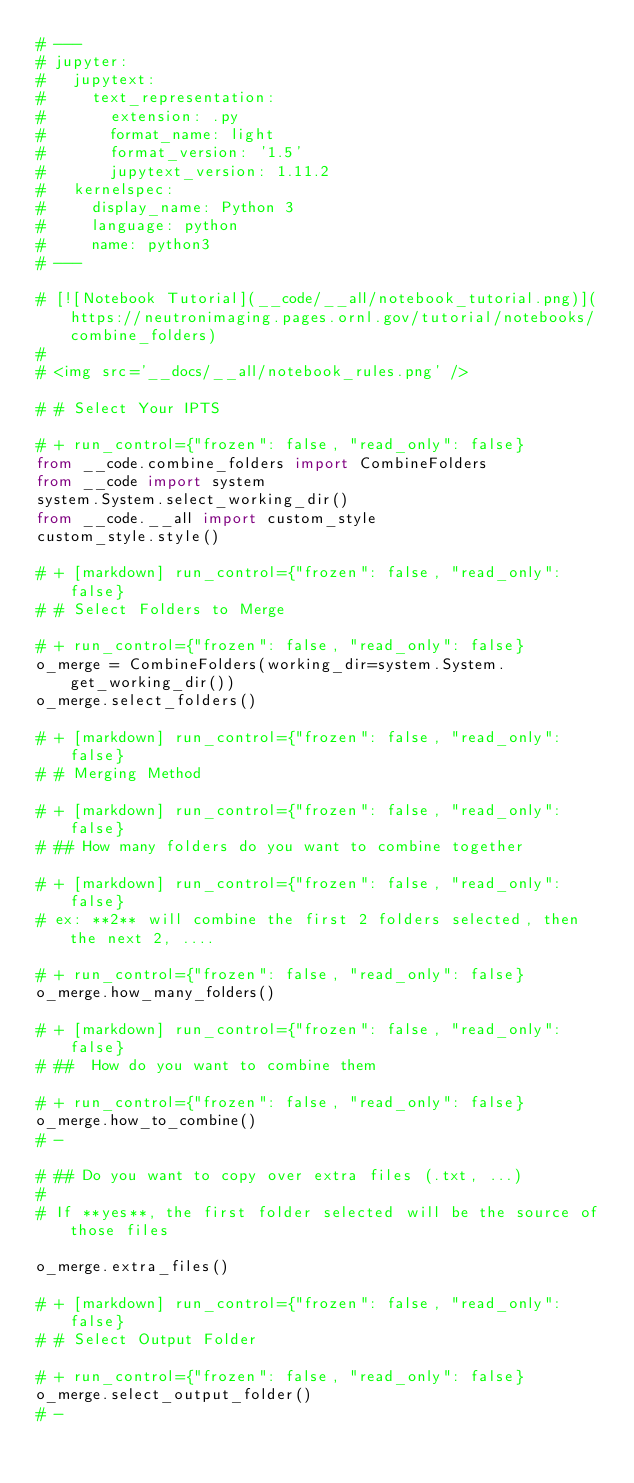<code> <loc_0><loc_0><loc_500><loc_500><_Python_># ---
# jupyter:
#   jupytext:
#     text_representation:
#       extension: .py
#       format_name: light
#       format_version: '1.5'
#       jupytext_version: 1.11.2
#   kernelspec:
#     display_name: Python 3
#     language: python
#     name: python3
# ---

# [![Notebook Tutorial](__code/__all/notebook_tutorial.png)](https://neutronimaging.pages.ornl.gov/tutorial/notebooks/combine_folders)
#
# <img src='__docs/__all/notebook_rules.png' />

# # Select Your IPTS 

# + run_control={"frozen": false, "read_only": false}
from __code.combine_folders import CombineFolders
from __code import system
system.System.select_working_dir()
from __code.__all import custom_style
custom_style.style()

# + [markdown] run_control={"frozen": false, "read_only": false}
# # Select Folders to Merge 

# + run_control={"frozen": false, "read_only": false}
o_merge = CombineFolders(working_dir=system.System.get_working_dir())
o_merge.select_folders()

# + [markdown] run_control={"frozen": false, "read_only": false}
# # Merging Method

# + [markdown] run_control={"frozen": false, "read_only": false}
# ## How many folders do you want to combine together

# + [markdown] run_control={"frozen": false, "read_only": false}
# ex: **2** will combine the first 2 folders selected, then the next 2, ....

# + run_control={"frozen": false, "read_only": false}
o_merge.how_many_folders()

# + [markdown] run_control={"frozen": false, "read_only": false}
# ##  How do you want to combine them

# + run_control={"frozen": false, "read_only": false}
o_merge.how_to_combine()
# -

# ## Do you want to copy over extra files (.txt, ...)
#
# If **yes**, the first folder selected will be the source of those files

o_merge.extra_files()

# + [markdown] run_control={"frozen": false, "read_only": false}
# # Select Output Folder 

# + run_control={"frozen": false, "read_only": false}
o_merge.select_output_folder()
# -


</code> 